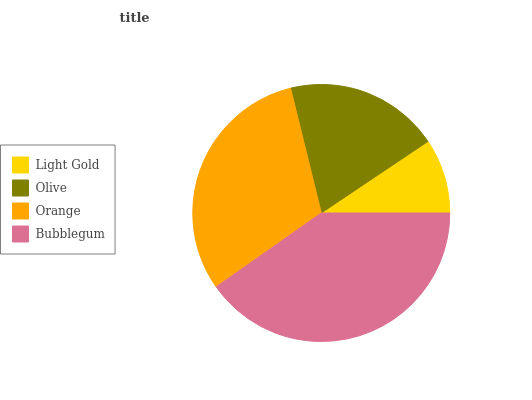Is Light Gold the minimum?
Answer yes or no. Yes. Is Bubblegum the maximum?
Answer yes or no. Yes. Is Olive the minimum?
Answer yes or no. No. Is Olive the maximum?
Answer yes or no. No. Is Olive greater than Light Gold?
Answer yes or no. Yes. Is Light Gold less than Olive?
Answer yes or no. Yes. Is Light Gold greater than Olive?
Answer yes or no. No. Is Olive less than Light Gold?
Answer yes or no. No. Is Orange the high median?
Answer yes or no. Yes. Is Olive the low median?
Answer yes or no. Yes. Is Bubblegum the high median?
Answer yes or no. No. Is Bubblegum the low median?
Answer yes or no. No. 